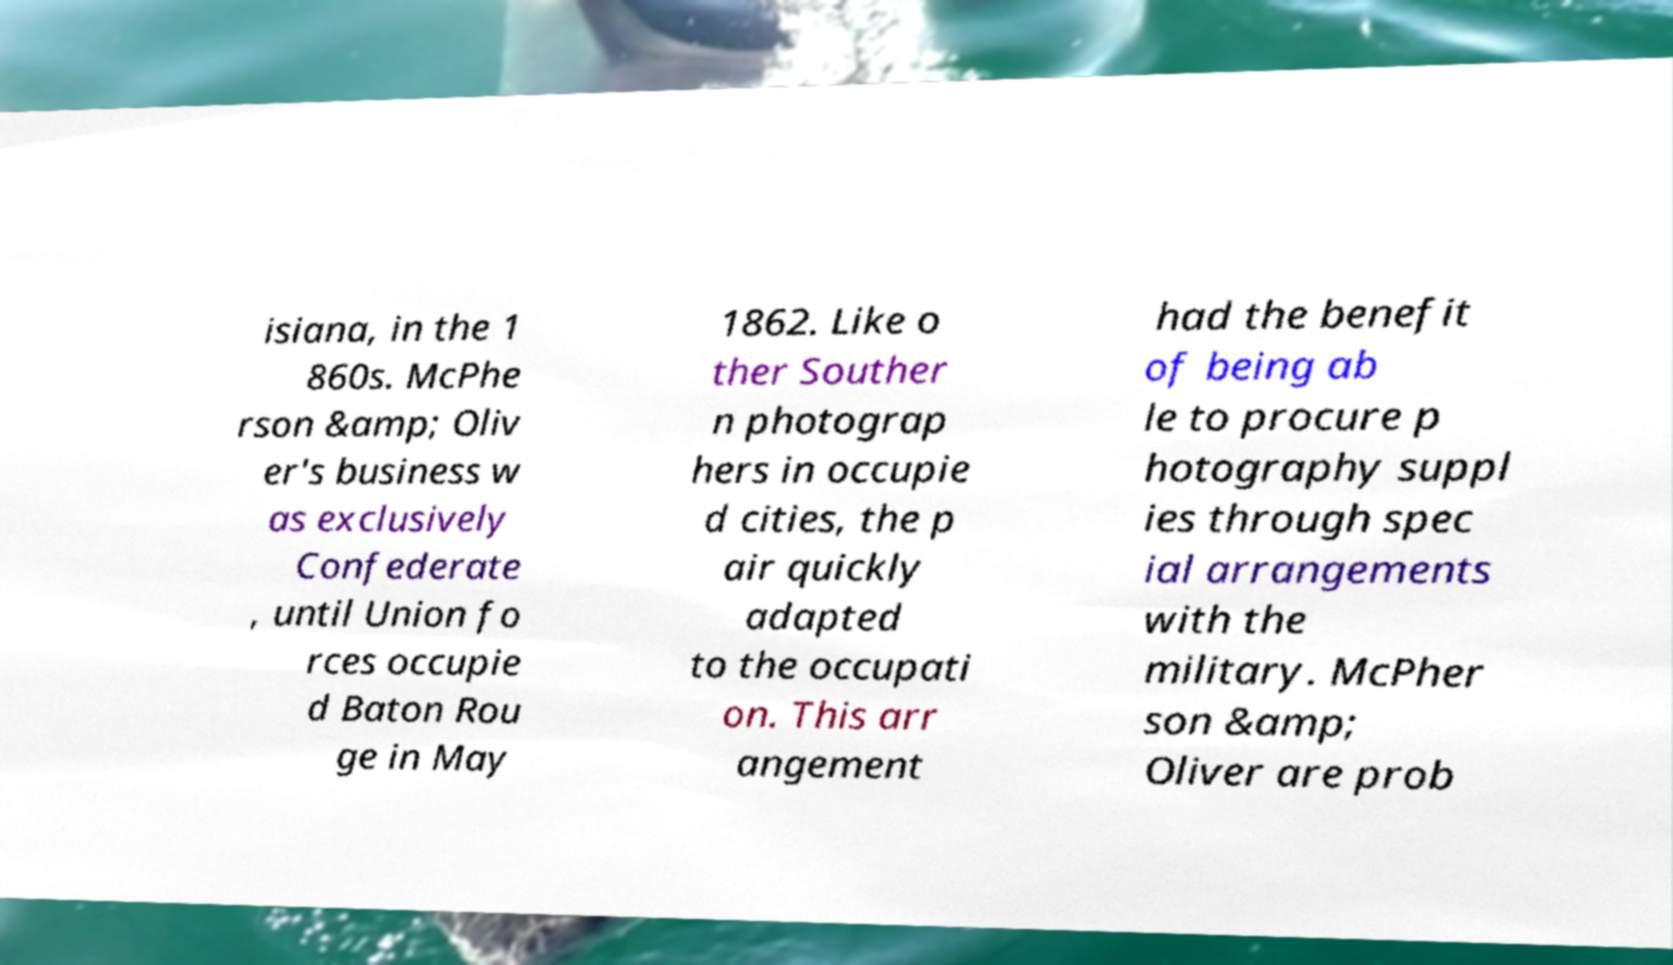Could you assist in decoding the text presented in this image and type it out clearly? isiana, in the 1 860s. McPhe rson &amp; Oliv er's business w as exclusively Confederate , until Union fo rces occupie d Baton Rou ge in May 1862. Like o ther Souther n photograp hers in occupie d cities, the p air quickly adapted to the occupati on. This arr angement had the benefit of being ab le to procure p hotography suppl ies through spec ial arrangements with the military. McPher son &amp; Oliver are prob 